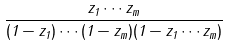<formula> <loc_0><loc_0><loc_500><loc_500>\frac { z _ { 1 } \cdots z _ { m } } { ( 1 - z _ { 1 } ) \cdots ( 1 - z _ { m } ) ( 1 - z _ { 1 } \cdots z _ { m } ) }</formula> 